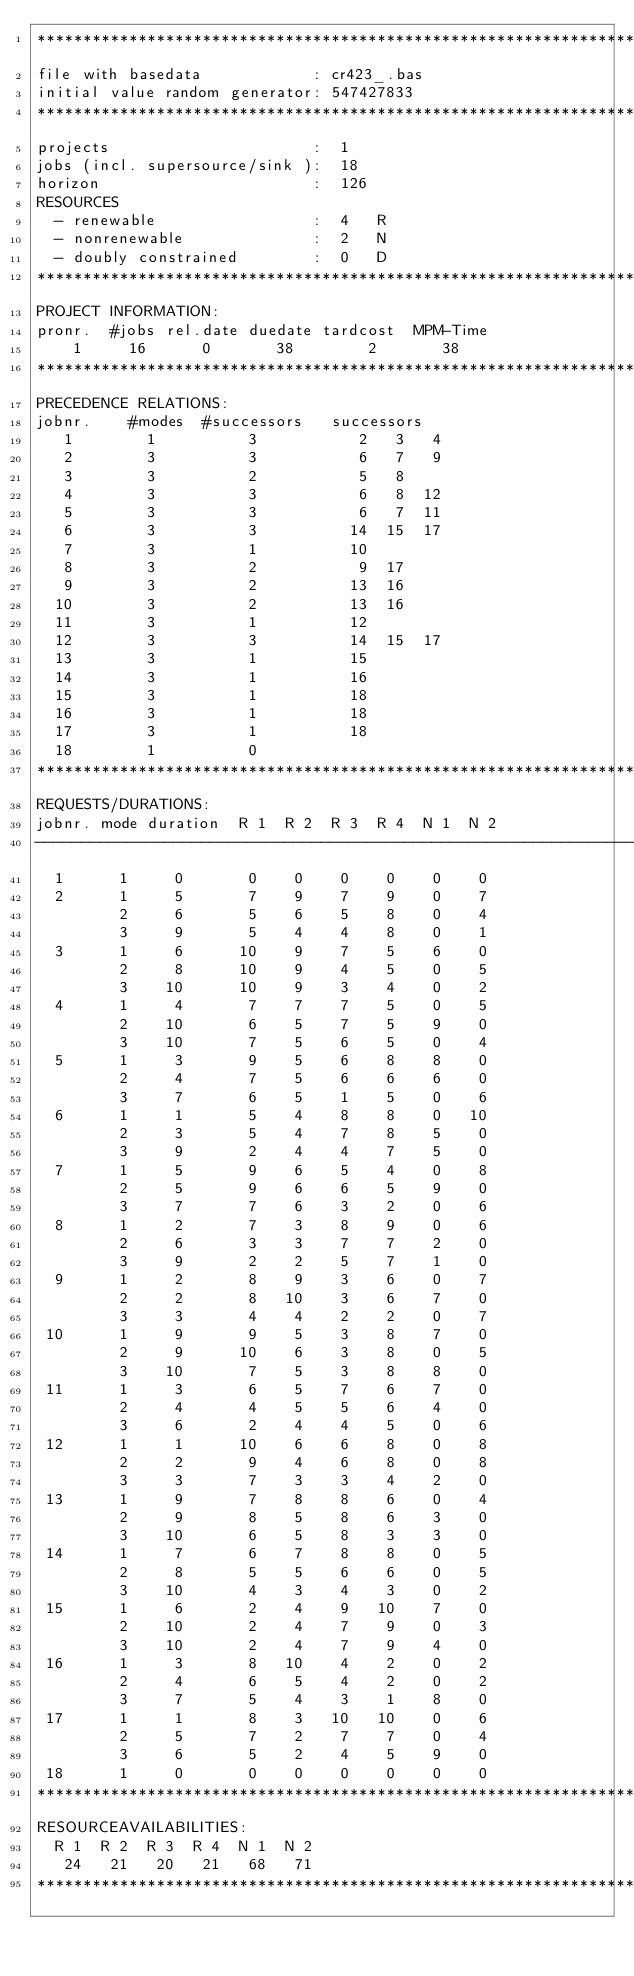Convert code to text. <code><loc_0><loc_0><loc_500><loc_500><_ObjectiveC_>************************************************************************
file with basedata            : cr423_.bas
initial value random generator: 547427833
************************************************************************
projects                      :  1
jobs (incl. supersource/sink ):  18
horizon                       :  126
RESOURCES
  - renewable                 :  4   R
  - nonrenewable              :  2   N
  - doubly constrained        :  0   D
************************************************************************
PROJECT INFORMATION:
pronr.  #jobs rel.date duedate tardcost  MPM-Time
    1     16      0       38        2       38
************************************************************************
PRECEDENCE RELATIONS:
jobnr.    #modes  #successors   successors
   1        1          3           2   3   4
   2        3          3           6   7   9
   3        3          2           5   8
   4        3          3           6   8  12
   5        3          3           6   7  11
   6        3          3          14  15  17
   7        3          1          10
   8        3          2           9  17
   9        3          2          13  16
  10        3          2          13  16
  11        3          1          12
  12        3          3          14  15  17
  13        3          1          15
  14        3          1          16
  15        3          1          18
  16        3          1          18
  17        3          1          18
  18        1          0        
************************************************************************
REQUESTS/DURATIONS:
jobnr. mode duration  R 1  R 2  R 3  R 4  N 1  N 2
------------------------------------------------------------------------
  1      1     0       0    0    0    0    0    0
  2      1     5       7    9    7    9    0    7
         2     6       5    6    5    8    0    4
         3     9       5    4    4    8    0    1
  3      1     6      10    9    7    5    6    0
         2     8      10    9    4    5    0    5
         3    10      10    9    3    4    0    2
  4      1     4       7    7    7    5    0    5
         2    10       6    5    7    5    9    0
         3    10       7    5    6    5    0    4
  5      1     3       9    5    6    8    8    0
         2     4       7    5    6    6    6    0
         3     7       6    5    1    5    0    6
  6      1     1       5    4    8    8    0   10
         2     3       5    4    7    8    5    0
         3     9       2    4    4    7    5    0
  7      1     5       9    6    5    4    0    8
         2     5       9    6    6    5    9    0
         3     7       7    6    3    2    0    6
  8      1     2       7    3    8    9    0    6
         2     6       3    3    7    7    2    0
         3     9       2    2    5    7    1    0
  9      1     2       8    9    3    6    0    7
         2     2       8   10    3    6    7    0
         3     3       4    4    2    2    0    7
 10      1     9       9    5    3    8    7    0
         2     9      10    6    3    8    0    5
         3    10       7    5    3    8    8    0
 11      1     3       6    5    7    6    7    0
         2     4       4    5    5    6    4    0
         3     6       2    4    4    5    0    6
 12      1     1      10    6    6    8    0    8
         2     2       9    4    6    8    0    8
         3     3       7    3    3    4    2    0
 13      1     9       7    8    8    6    0    4
         2     9       8    5    8    6    3    0
         3    10       6    5    8    3    3    0
 14      1     7       6    7    8    8    0    5
         2     8       5    5    6    6    0    5
         3    10       4    3    4    3    0    2
 15      1     6       2    4    9   10    7    0
         2    10       2    4    7    9    0    3
         3    10       2    4    7    9    4    0
 16      1     3       8   10    4    2    0    2
         2     4       6    5    4    2    0    2
         3     7       5    4    3    1    8    0
 17      1     1       8    3   10   10    0    6
         2     5       7    2    7    7    0    4
         3     6       5    2    4    5    9    0
 18      1     0       0    0    0    0    0    0
************************************************************************
RESOURCEAVAILABILITIES:
  R 1  R 2  R 3  R 4  N 1  N 2
   24   21   20   21   68   71
************************************************************************
</code> 